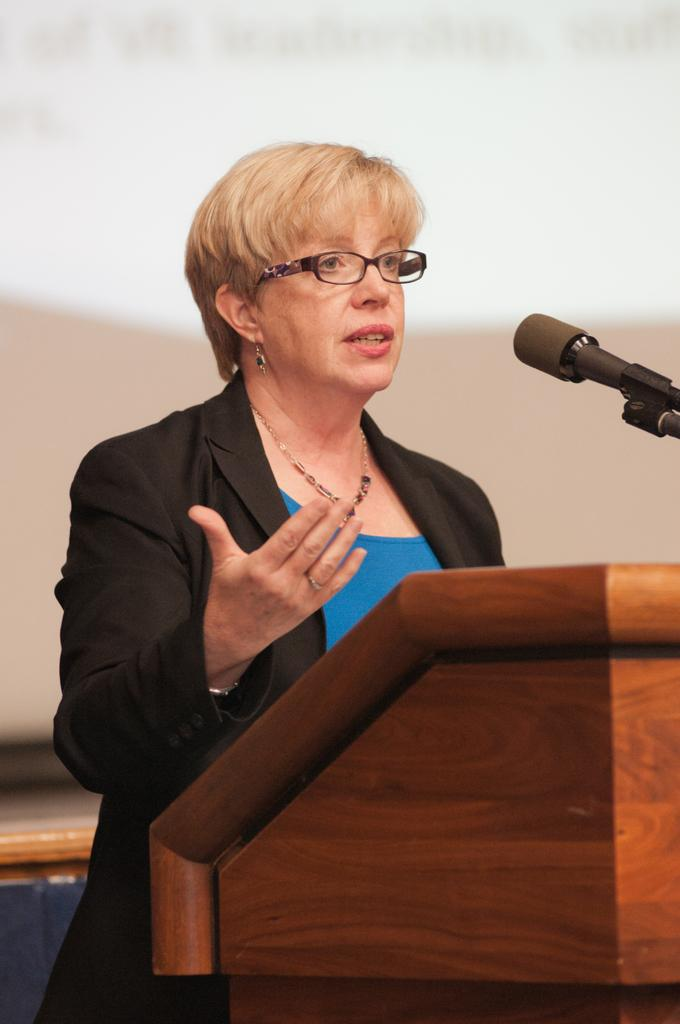What is the main subject of the image? There is a person in the image. What is the person wearing? The person is wearing a black blazer and a blue color shirt. What is in front of the person? There is a podium in front of the person. What is on the podium? There is a microphone on the podium. What is the color of the background in the image? The background of the image is white. What type of weather can be seen in the image? There is no weather visible in the image, as it is an indoor setting with a white background. Are there any horses present in the image? No, there are no horses present in the image. 